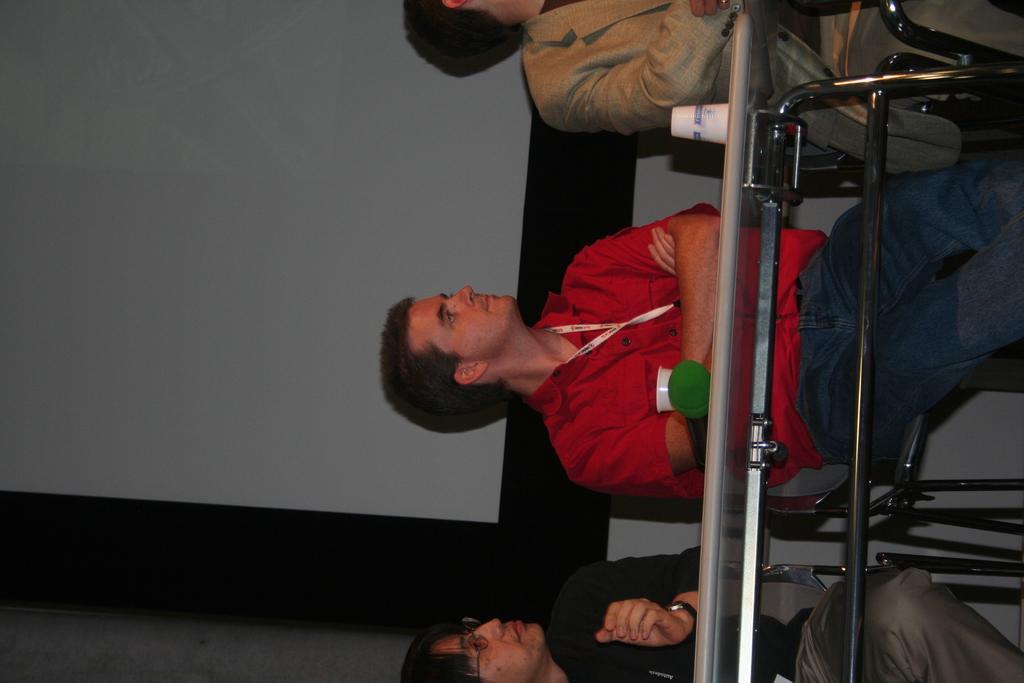Describe this image in one or two sentences. In this picture there are three people sitting on the chairs behind the table and there are cups and there is an object on the table. At the back it looks like a screen. 